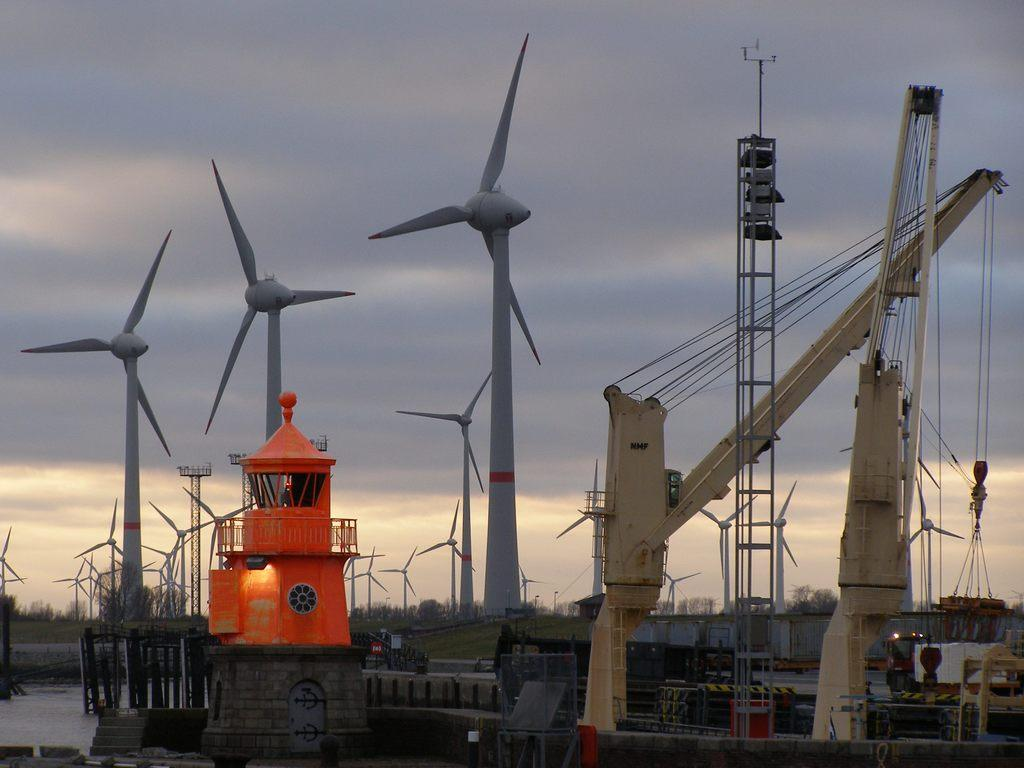What is the main subject of the image? The main subject of the image is many windmills. How would you describe the sky in the image? The sky is cloudy in the image. What type of terrain is visible in the image? There is grassy land visible in the image. Are there any other natural elements present in the image? Yes, there are many trees in the image. How many oranges are being picked by the laborer in the image? There is no laborer or oranges present in the image. What is the starting point for the windmills in the image? The image does not provide information about a starting point for the windmills. 